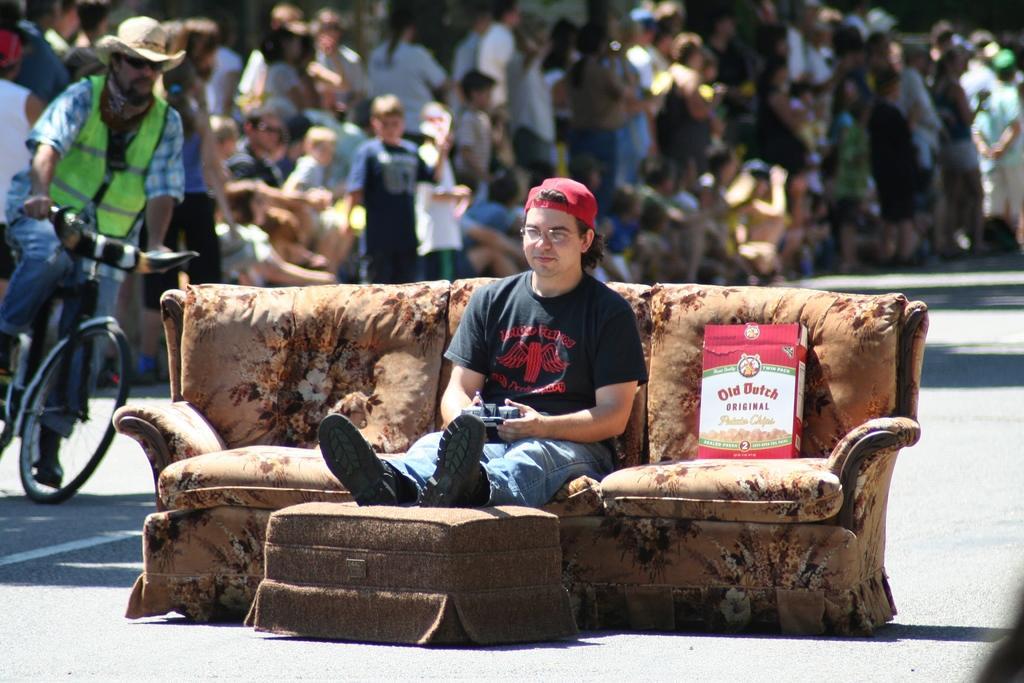How would you summarize this image in a sentence or two? In this picture we can see a person sitting on the couch and holding a remote in his hands. In the background we can see a person riding a bicycle, there are few more people standing on the left side. 